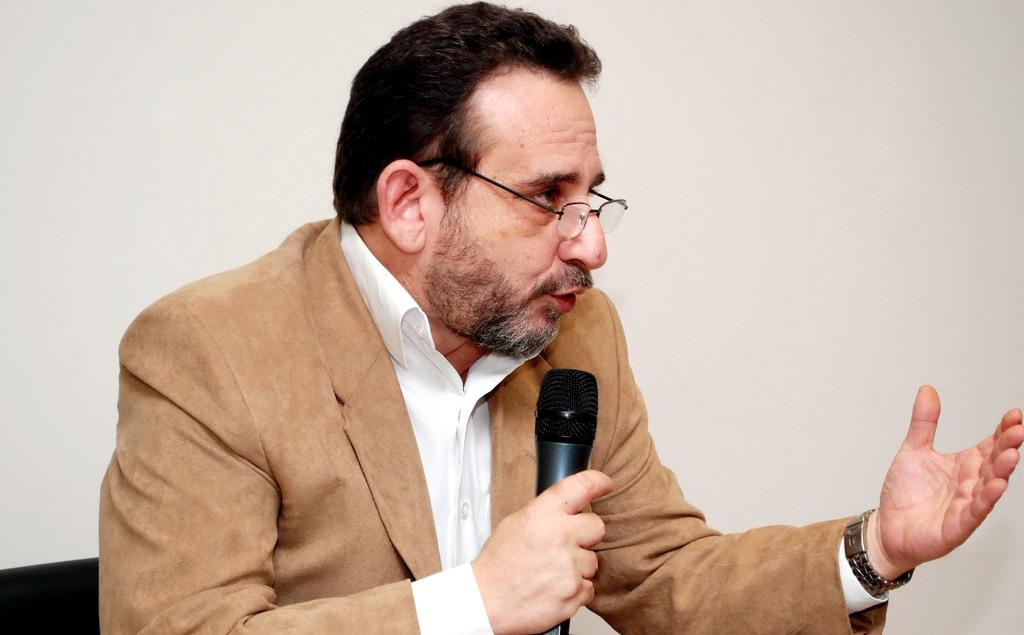Who is the main subject in the image? There is a man in the image. What is the man doing in the image? The man is talking in the image. How is the man talking in the image? The man is using a microphone to talk in the image. What type of treatment is the man receiving while using the rod in the image? There is no rod present in the image, and the man is not receiving any treatment; he is simply talking using a microphone. 